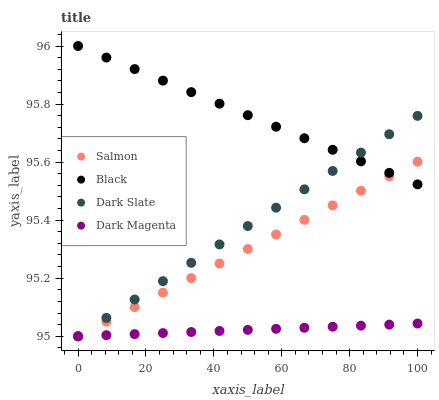Does Dark Magenta have the minimum area under the curve?
Answer yes or no. Yes. Does Black have the maximum area under the curve?
Answer yes or no. Yes. Does Salmon have the minimum area under the curve?
Answer yes or no. No. Does Salmon have the maximum area under the curve?
Answer yes or no. No. Is Black the smoothest?
Answer yes or no. Yes. Is Salmon the roughest?
Answer yes or no. Yes. Is Dark Magenta the smoothest?
Answer yes or no. No. Is Dark Magenta the roughest?
Answer yes or no. No. Does Salmon have the lowest value?
Answer yes or no. Yes. Does Black have the highest value?
Answer yes or no. Yes. Does Salmon have the highest value?
Answer yes or no. No. Is Dark Magenta less than Black?
Answer yes or no. Yes. Is Black greater than Dark Magenta?
Answer yes or no. Yes. Does Dark Magenta intersect Salmon?
Answer yes or no. Yes. Is Dark Magenta less than Salmon?
Answer yes or no. No. Is Dark Magenta greater than Salmon?
Answer yes or no. No. Does Dark Magenta intersect Black?
Answer yes or no. No. 